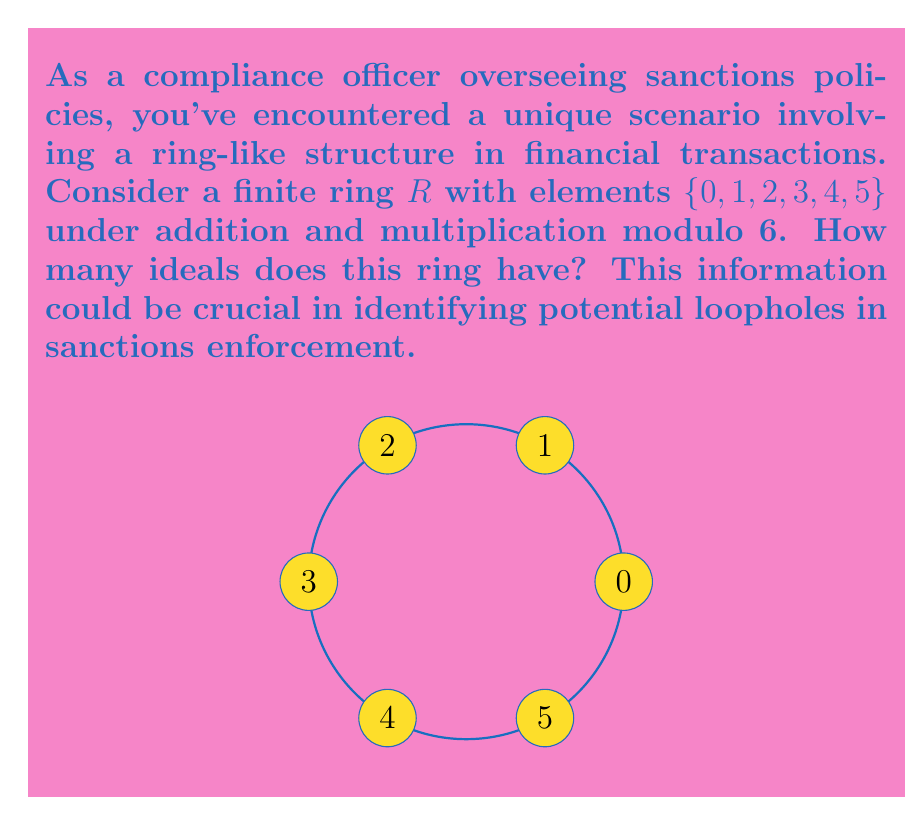Could you help me with this problem? To find the number of ideals in the given ring $R = \mathbb{Z}_6$, we need to follow these steps:

1) First, recall that an ideal $I$ of a ring $R$ is a subset of $R$ that satisfies:
   a) $(I, +)$ is a subgroup of $(R, +)$
   b) For all $r \in R$ and $i \in I$, both $ri$ and $ir$ are in $I$

2) In $\mathbb{Z}_6$, the possible ideals are:
   - $\{0\}$ (always an ideal)
   - $\{0, 2, 4\}$ (generated by 2)
   - $\{0, 3\}$ (generated by 3)
   - $\mathbb{Z}_6$ itself (always an ideal)

3) Let's verify each:

   a) $\{0\}$: Trivially an ideal.
   
   b) $\{0, 2, 4\}$:
      - Closed under addition: $2+2=4, 2+4=0, 4+4=2$ (mod 6)
      - Closed under multiplication by any element in $\mathbb{Z}_6$
   
   c) $\{0, 3\}$:
      - Closed under addition: $3+3=0$ (mod 6)
      - Closed under multiplication by any element in $\mathbb{Z}_6$
   
   d) $\mathbb{Z}_6$: Trivially an ideal.

4) Note that $\{0, 1, 2, 3, 4, 5\}$ is not a proper ideal as it's the entire ring.

5) There are no other ideals in this ring. For example, $\{0, 1\}$ is not an ideal because $1 \cdot 2 = 2 \notin \{0, 1\}$.

Therefore, we have found all the ideals of $\mathbb{Z}_6$.
Answer: 4 ideals 